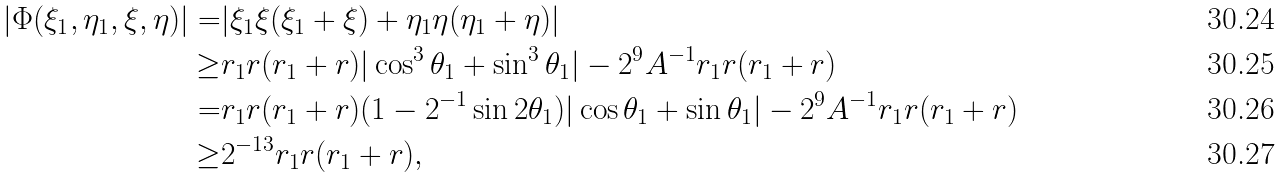<formula> <loc_0><loc_0><loc_500><loc_500>| \Phi ( \xi _ { 1 } , \eta _ { 1 } , \xi , \eta ) | = & | \xi _ { 1 } \xi ( \xi _ { 1 } + \xi ) + \eta _ { 1 } \eta ( \eta _ { 1 } + \eta ) | \\ \geq & r _ { 1 } r ( r _ { 1 } + r ) | \cos ^ { 3 } \theta _ { 1 } + \sin ^ { 3 } \theta _ { 1 } | - 2 ^ { 9 } A ^ { - 1 } r _ { 1 } r ( r _ { 1 } + r ) \\ = & r _ { 1 } r ( r _ { 1 } + r ) ( 1 - 2 ^ { - 1 } \sin 2 \theta _ { 1 } ) | \cos \theta _ { 1 } + \sin \theta _ { 1 } | - 2 ^ { 9 } A ^ { - 1 } r _ { 1 } r ( r _ { 1 } + r ) \\ \geq & 2 ^ { - 1 3 } r _ { 1 } r ( r _ { 1 } + r ) ,</formula> 